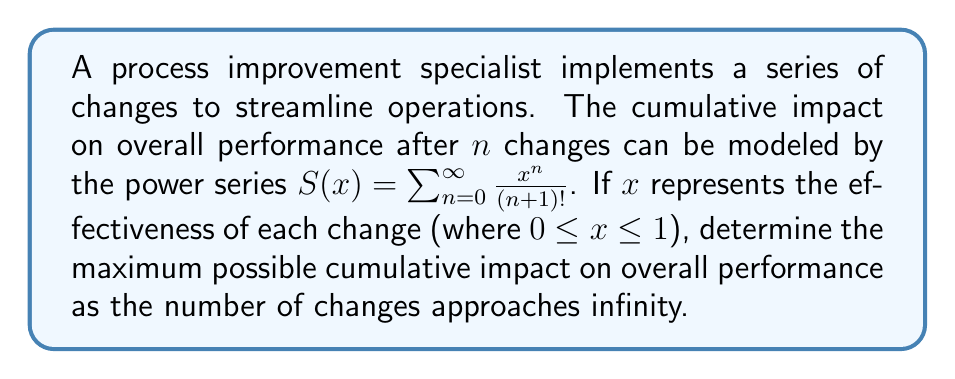Provide a solution to this math problem. 1) First, we need to recognize that this power series is a well-known function:
   $S(x) = \sum_{n=0}^{\infty} \frac{x^n}{(n+1)!} = \frac{e^x - 1}{x}$

2) This function is defined for all real $x$ except $x=0$. However, we can extend its domain to include $x=0$ by defining $S(0) = 1$ (using L'Hôpital's rule).

3) Given that $x$ represents the effectiveness of each change and is bounded between 0 and 1, we need to find the maximum value of $S(x)$ in the interval $[0,1]$.

4) To find the maximum, we can differentiate $S(x)$ with respect to $x$:
   $S'(x) = \frac{xe^x - (e^x - 1)}{x^2} = \frac{xe^x - e^x + 1}{x^2}$

5) Setting $S'(x) = 0$:
   $xe^x - e^x + 1 = 0$
   $e^x(x - 1) + 1 = 0$
   $e^x = \frac{1}{1-x}$

6) This equation has no algebraic solution for $x$ in the interval $(0,1)$. However, we can observe that:
   - As $x \to 0^+$, $S(x) \to 1$
   - As $x \to 1^-$, $S(x) \to e - 1 \approx 1.718$

7) Therefore, the maximum value of $S(x)$ in $[0,1]$ occurs at $x=1$, which gives:
   $S(1) = e - 1 \approx 1.718$
Answer: $e - 1$ 